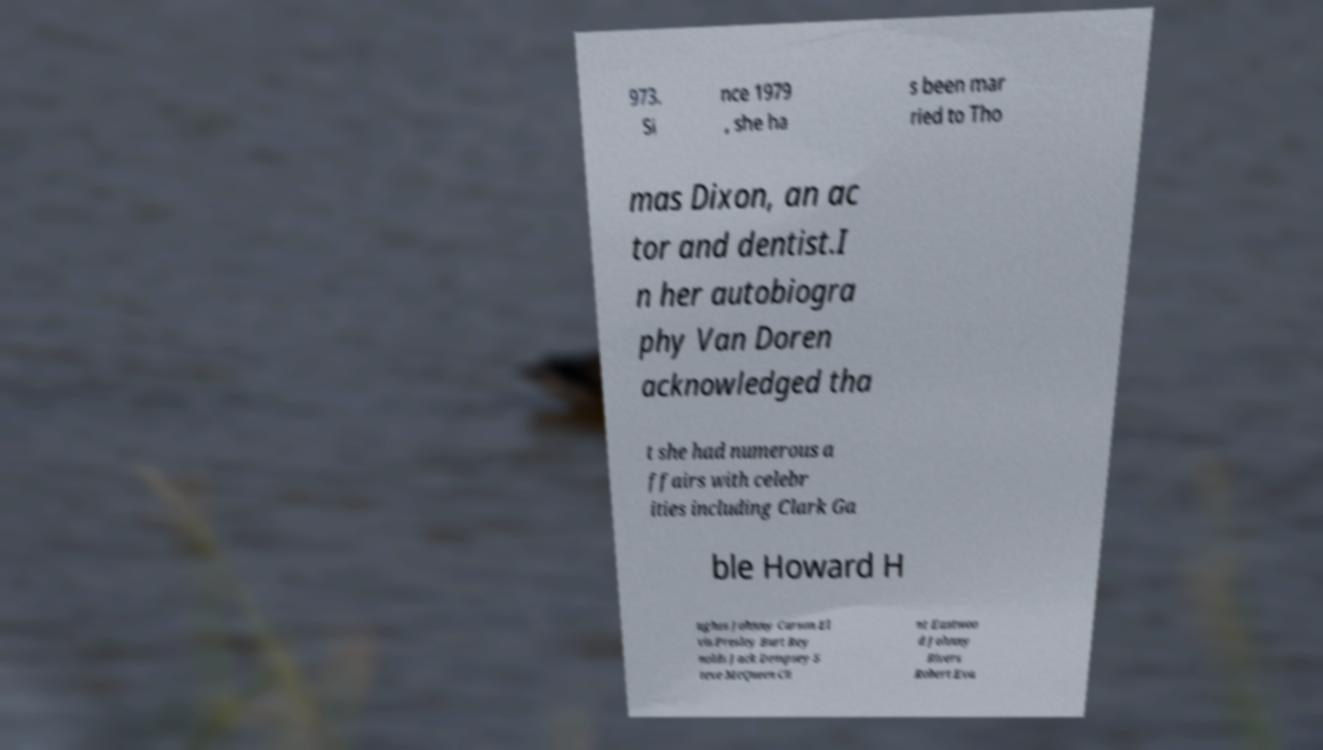What messages or text are displayed in this image? I need them in a readable, typed format. 973. Si nce 1979 , she ha s been mar ried to Tho mas Dixon, an ac tor and dentist.I n her autobiogra phy Van Doren acknowledged tha t she had numerous a ffairs with celebr ities including Clark Ga ble Howard H ughes Johnny Carson El vis Presley Burt Rey nolds Jack Dempsey S teve McQueen Cli nt Eastwoo d Johnny Rivers Robert Eva 